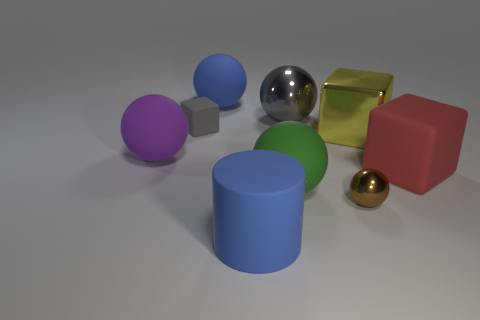What material is the big object that is the same color as the large cylinder?
Give a very brief answer. Rubber. The thing that is the same color as the rubber cylinder is what shape?
Offer a very short reply. Sphere. What number of gray things are either big shiny things or rubber things?
Provide a short and direct response. 2. There is a big blue object that is in front of the large purple thing; is it the same shape as the large red thing?
Offer a terse response. No. Is the number of big yellow objects that are in front of the tiny block greater than the number of tiny brown cylinders?
Make the answer very short. Yes. How many blue rubber balls have the same size as the green thing?
Offer a very short reply. 1. The matte thing that is the same color as the big shiny ball is what size?
Provide a succinct answer. Small. What number of objects are small metallic things or large things that are behind the red thing?
Offer a very short reply. 5. What is the color of the big thing that is both on the left side of the blue cylinder and behind the gray cube?
Offer a terse response. Blue. Do the brown thing and the yellow block have the same size?
Keep it short and to the point. No. 